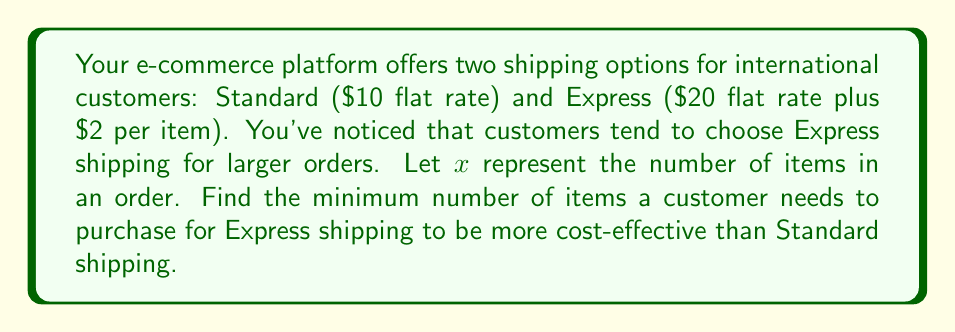Can you solve this math problem? Let's approach this step-by-step:

1) First, let's set up equations for each shipping method:
   
   Standard shipping cost: $S = 10$ (flat rate)
   Express shipping cost: $E = 20 + 2x$ (flat rate plus $2 per item)

2) We want to find when Express becomes cheaper than Standard:
   
   $20 + 2x < 10$

3) Solve the inequality:
   
   $20 + 2x < 10$
   $2x < -10$
   $x < -5$

4) However, since $x$ represents the number of items, it can't be negative. So we need to find the point where they're equal and then add 1 to get the first point where Express is cheaper.

5) Set up the equation:
   
   $20 + 2x = 10$

6) Solve for $x$:
   
   $2x = -10$
   $x = -5$

7) Since $x$ must be a positive integer, the smallest value where Express becomes cheaper is $-5 + 1 + 1 = -3$, or 6 items.

Therefore, a customer needs to purchase a minimum of 6 items for Express shipping to be more cost-effective than Standard shipping.
Answer: 6 items 